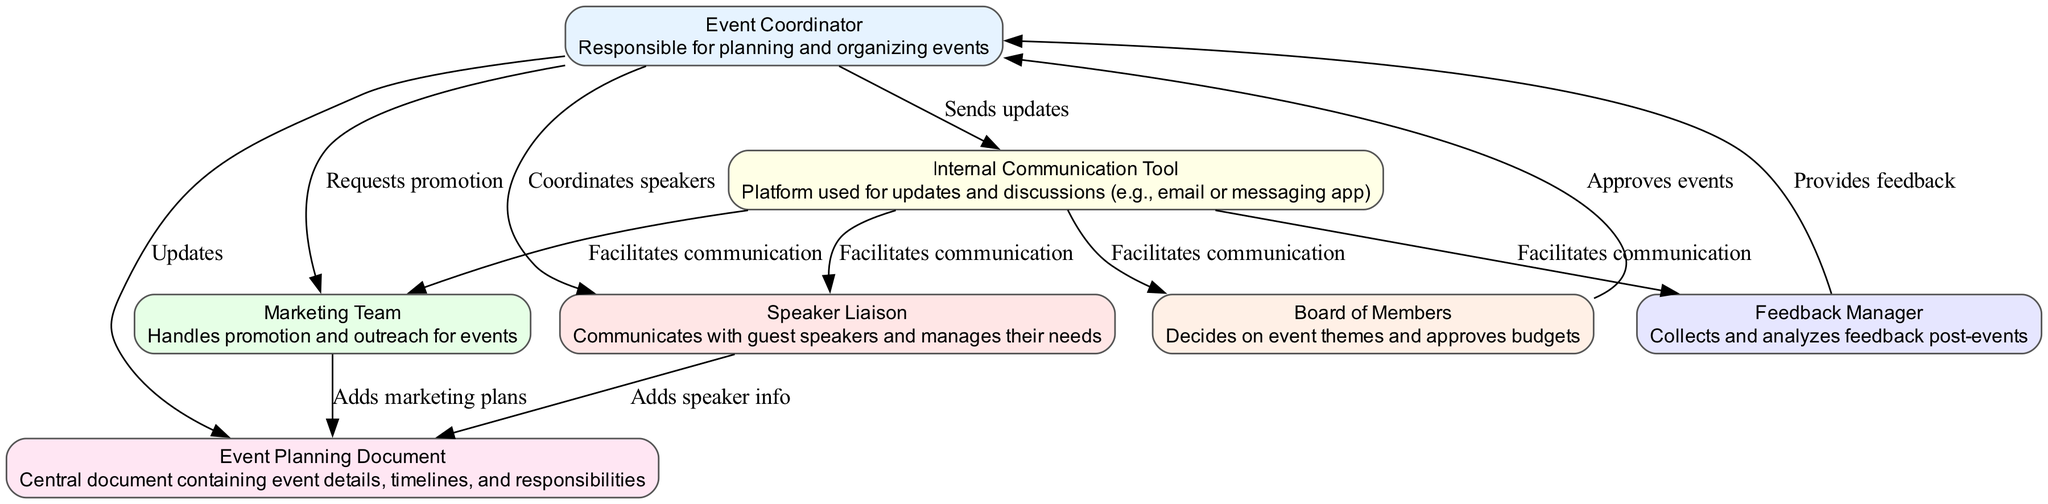What is the ID of the Event Coordinator? The ID of the Event Coordinator is "1", which is directly provided in the elements list of the diagram.
Answer: 1 How many nodes are in the diagram? The diagram includes a total of 7 nodes, which are represented by the 7 unique elements listed in the data.
Answer: 7 What action does the Event Coordinator take towards the Marketing Team? The Event Coordinator requests promotion from the Marketing Team as indicated by the edge labeled "Requests promotion" that connects them.
Answer: Requests promotion Who communicates with the guest speakers? The Speaker Liaison is responsible for communicating with guest speakers as outlined in the description for this role in the diagram.
Answer: Speaker Liaison What document contains event details? The Event Planning Document contains event details, timelines, and responsibilities as noted in the element description.
Answer: Event Planning Document Which entity approves budgets? The Board of Members approves budgets, as indicated by the flow connecting it to the Event Coordinator for event approvals.
Answer: Board of Members What is the number of edges connecting the Event Coordinator to other nodes? There are 4 edges connecting the Event Coordinator to other nodes (Speaker Liaison, Marketing Team, Event Planning Document, and Internal Communication Tool) as shown in the flow connections.
Answer: 4 What type of communication tool is used for updates? The Internal Communication Tool is used for updates and discussions, as noted in its description in the diagram.
Answer: Internal Communication Tool How does the Feedback Manager provide input to the Event Coordinator? The Feedback Manager provides feedback to the Event Coordinator, indicated by the edge labeled "Provides feedback" that goes from the Feedback Manager to the Event Coordinator.
Answer: Provides feedback 